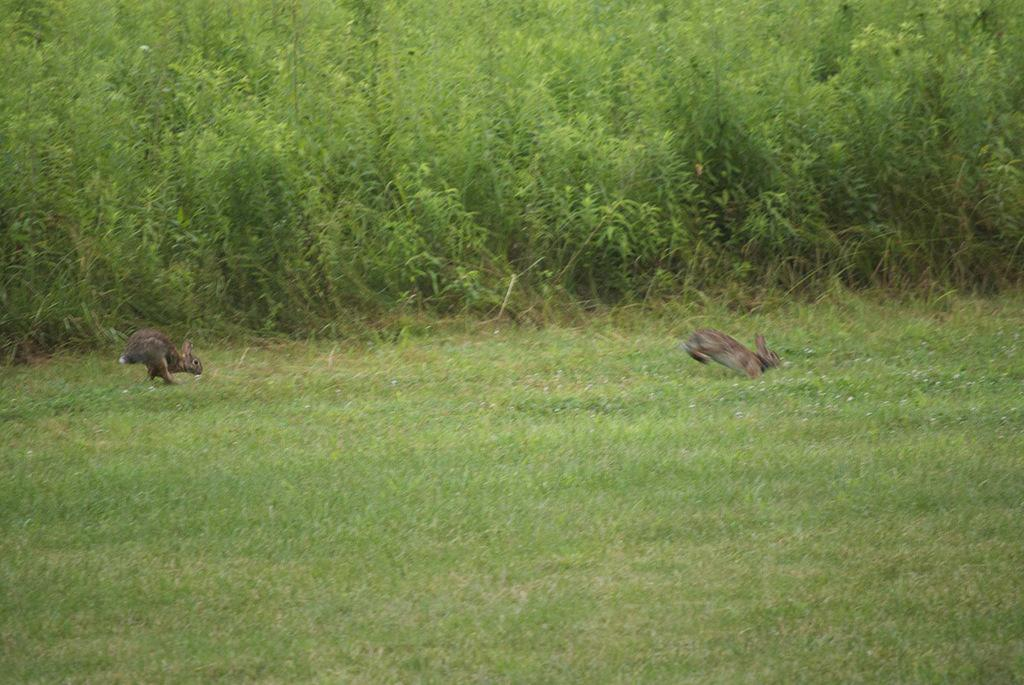How many rabbits are in the image? There are two rabbits in the image. What are the rabbits doing in the image? The rabbits are running. What type of surface can be seen in the image? The ground is visible in the image. What can be seen in the background of the image? There are plants in the background of the image. What type of vegetation is on the ground? There is grass on the ground. Can you see a lake in the image? There is no lake present in the image. Are there any bubbles visible in the image? There are no bubbles visible in the image. 